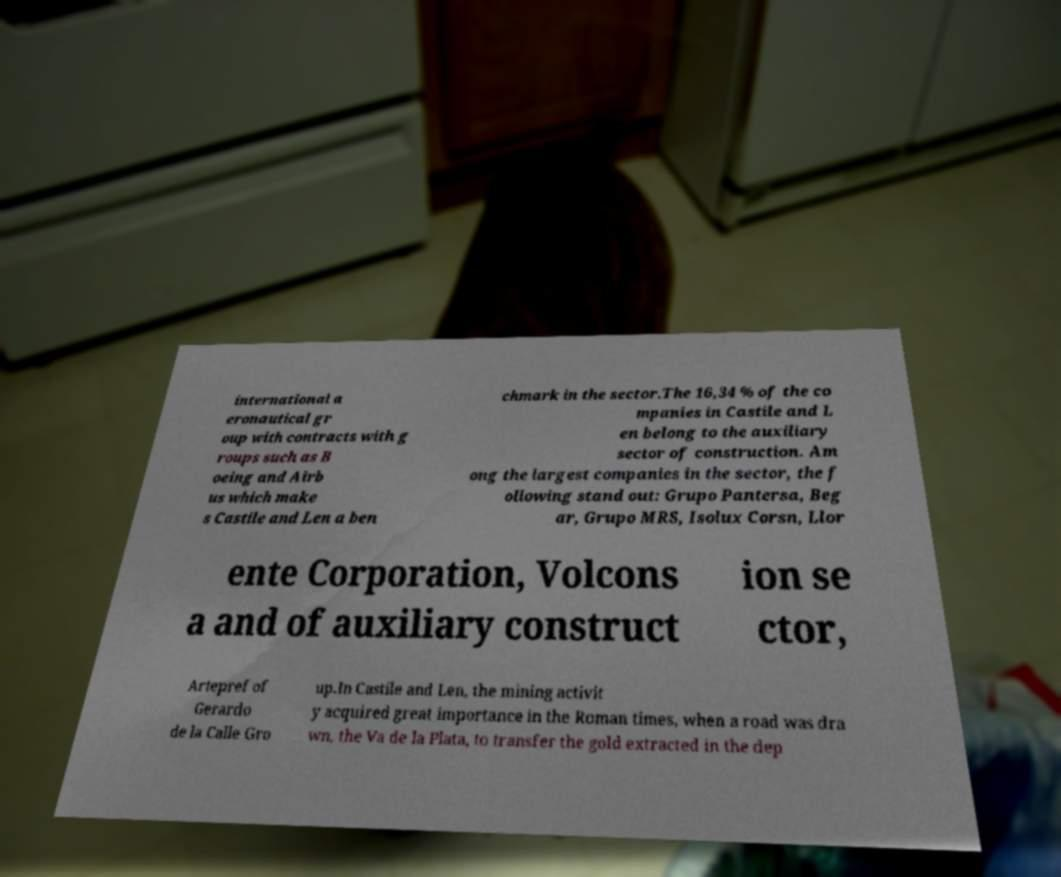Please identify and transcribe the text found in this image. international a eronautical gr oup with contracts with g roups such as B oeing and Airb us which make s Castile and Len a ben chmark in the sector.The 16,34 % of the co mpanies in Castile and L en belong to the auxiliary sector of construction. Am ong the largest companies in the sector, the f ollowing stand out: Grupo Pantersa, Beg ar, Grupo MRS, Isolux Corsn, Llor ente Corporation, Volcons a and of auxiliary construct ion se ctor, Artepref of Gerardo de la Calle Gro up.In Castile and Len, the mining activit y acquired great importance in the Roman times, when a road was dra wn, the Va de la Plata, to transfer the gold extracted in the dep 